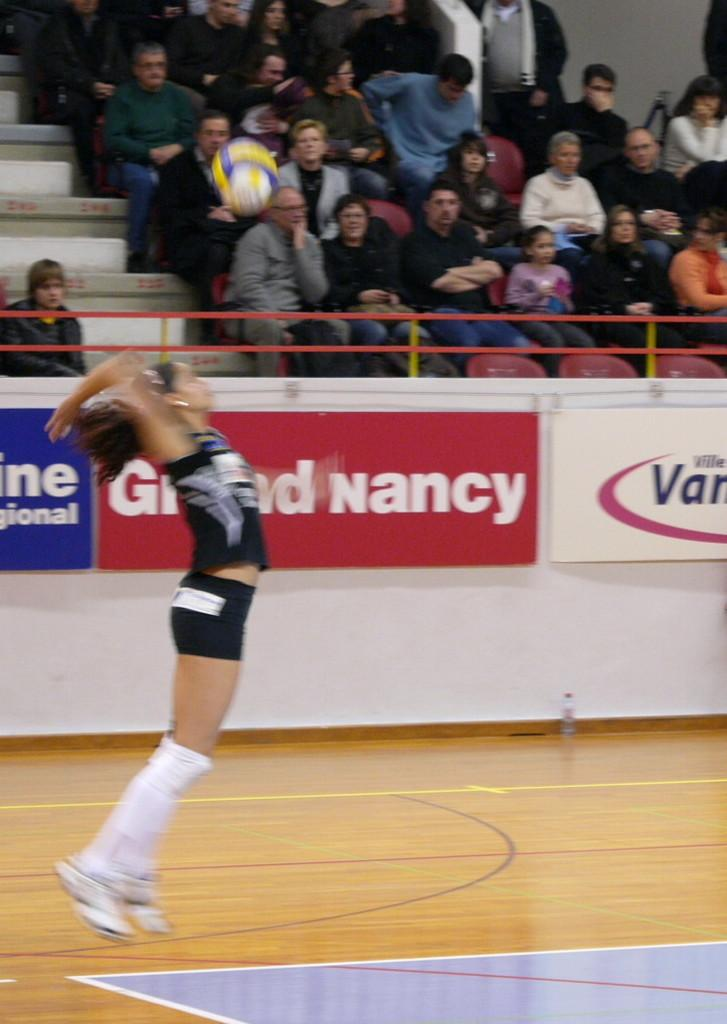Who is the main subject in the image? There is a girl in the image. What is the girl doing in the image? The girl is hitting a ball. What type of footwear is the girl wearing? The girl is wearing shoes. What can be seen in the background of the image? There are people sitting on stairs and hoardings visible in the image. What type of bone can be seen in the girl's hand in the image? There is no bone present in the girl's hand in the image; she is holding a ball. 